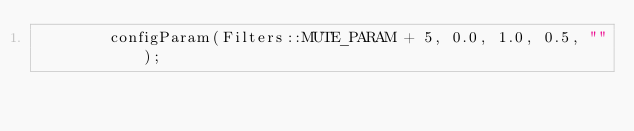Convert code to text. <code><loc_0><loc_0><loc_500><loc_500><_C++_>        configParam(Filters::MUTE_PARAM + 5, 0.0, 1.0, 0.5, "");</code> 